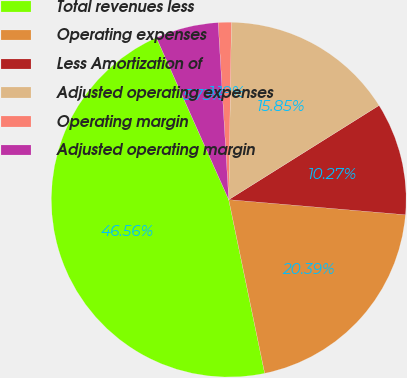<chart> <loc_0><loc_0><loc_500><loc_500><pie_chart><fcel>Total revenues less<fcel>Operating expenses<fcel>Less Amortization of<fcel>Adjusted operating expenses<fcel>Operating margin<fcel>Adjusted operating margin<nl><fcel>46.56%<fcel>20.39%<fcel>10.27%<fcel>15.85%<fcel>1.19%<fcel>5.73%<nl></chart> 